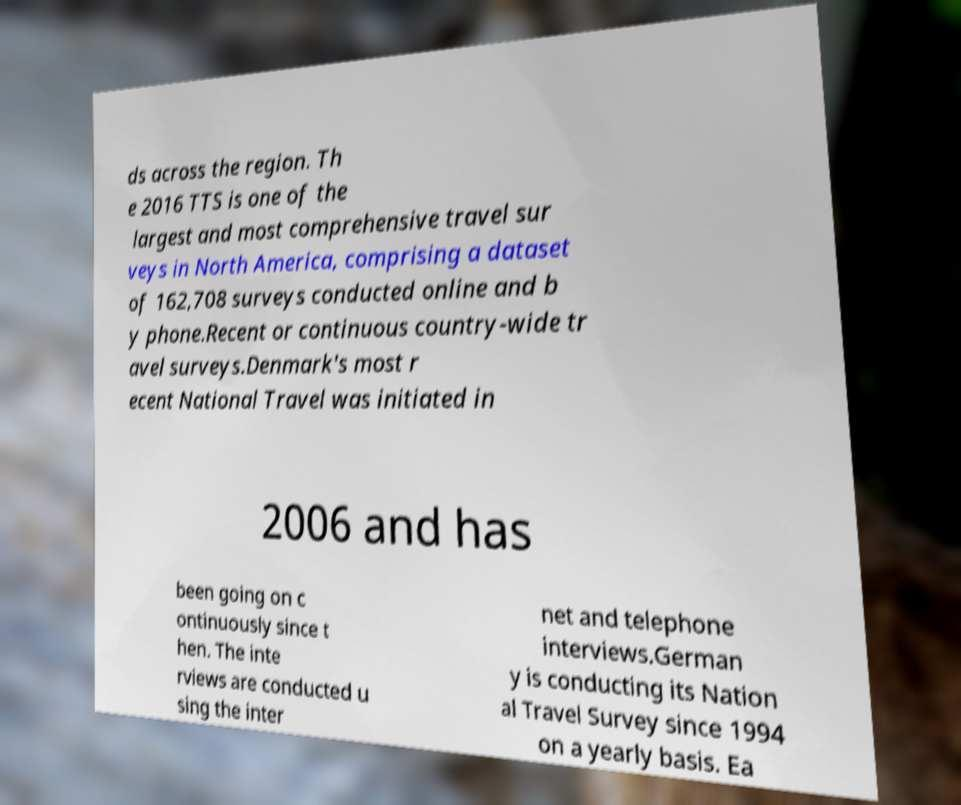I need the written content from this picture converted into text. Can you do that? ds across the region. Th e 2016 TTS is one of the largest and most comprehensive travel sur veys in North America, comprising a dataset of 162,708 surveys conducted online and b y phone.Recent or continuous country-wide tr avel surveys.Denmark's most r ecent National Travel was initiated in 2006 and has been going on c ontinuously since t hen. The inte rviews are conducted u sing the inter net and telephone interviews.German y is conducting its Nation al Travel Survey since 1994 on a yearly basis. Ea 